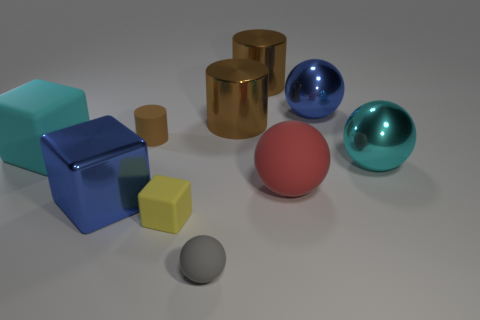Subtract all cylinders. How many objects are left? 7 Subtract all large cyan matte spheres. Subtract all cyan shiny things. How many objects are left? 9 Add 5 cyan rubber cubes. How many cyan rubber cubes are left? 6 Add 2 blue balls. How many blue balls exist? 3 Subtract 0 cyan cylinders. How many objects are left? 10 